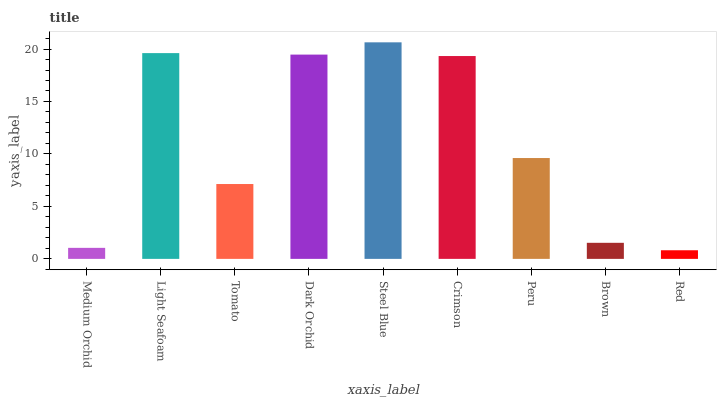Is Red the minimum?
Answer yes or no. Yes. Is Steel Blue the maximum?
Answer yes or no. Yes. Is Light Seafoam the minimum?
Answer yes or no. No. Is Light Seafoam the maximum?
Answer yes or no. No. Is Light Seafoam greater than Medium Orchid?
Answer yes or no. Yes. Is Medium Orchid less than Light Seafoam?
Answer yes or no. Yes. Is Medium Orchid greater than Light Seafoam?
Answer yes or no. No. Is Light Seafoam less than Medium Orchid?
Answer yes or no. No. Is Peru the high median?
Answer yes or no. Yes. Is Peru the low median?
Answer yes or no. Yes. Is Medium Orchid the high median?
Answer yes or no. No. Is Tomato the low median?
Answer yes or no. No. 